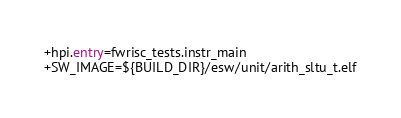<code> <loc_0><loc_0><loc_500><loc_500><_FORTRAN_>+hpi.entry=fwrisc_tests.instr_main
+SW_IMAGE=${BUILD_DIR}/esw/unit/arith_sltu_t.elf
</code> 